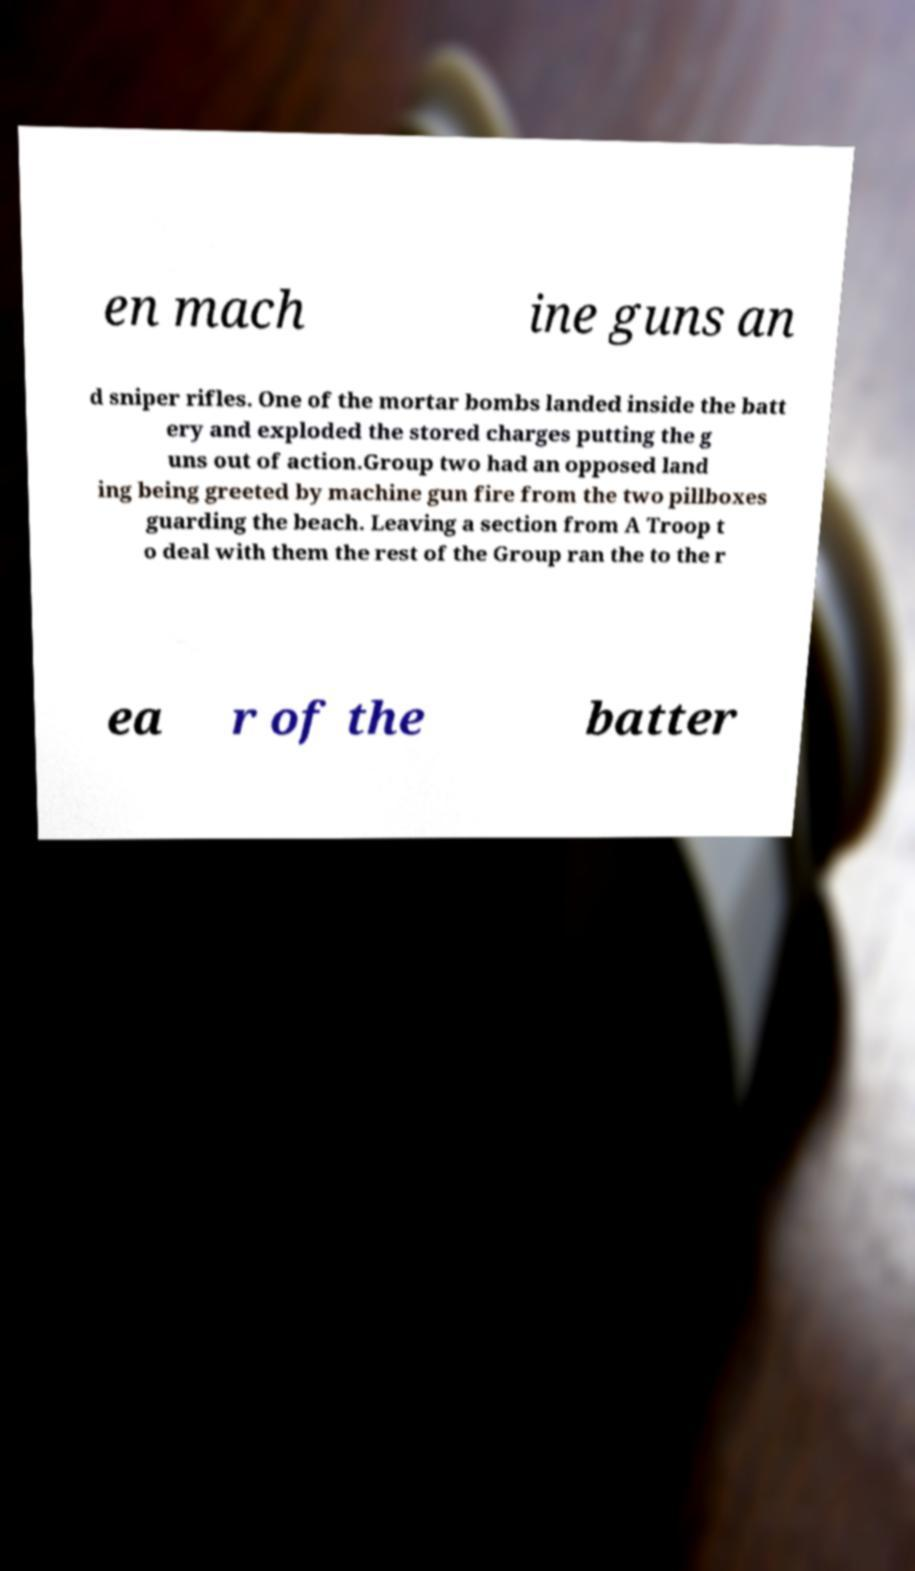For documentation purposes, I need the text within this image transcribed. Could you provide that? en mach ine guns an d sniper rifles. One of the mortar bombs landed inside the batt ery and exploded the stored charges putting the g uns out of action.Group two had an opposed land ing being greeted by machine gun fire from the two pillboxes guarding the beach. Leaving a section from A Troop t o deal with them the rest of the Group ran the to the r ea r of the batter 